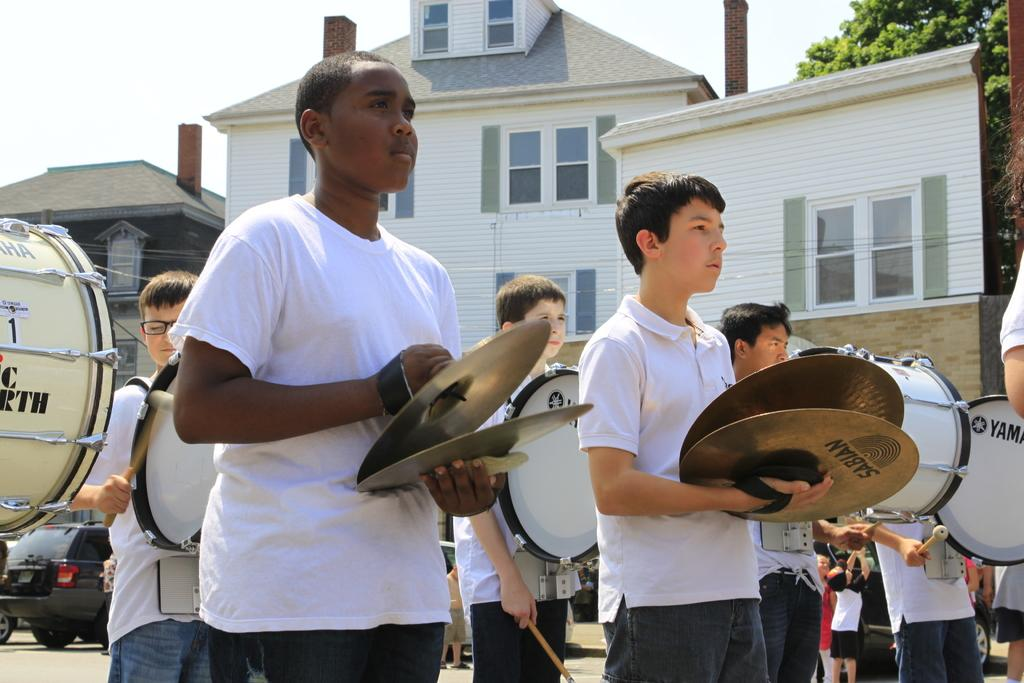<image>
Relay a brief, clear account of the picture shown. Boys in a marching band playing the drum and Sabian gold plates. 